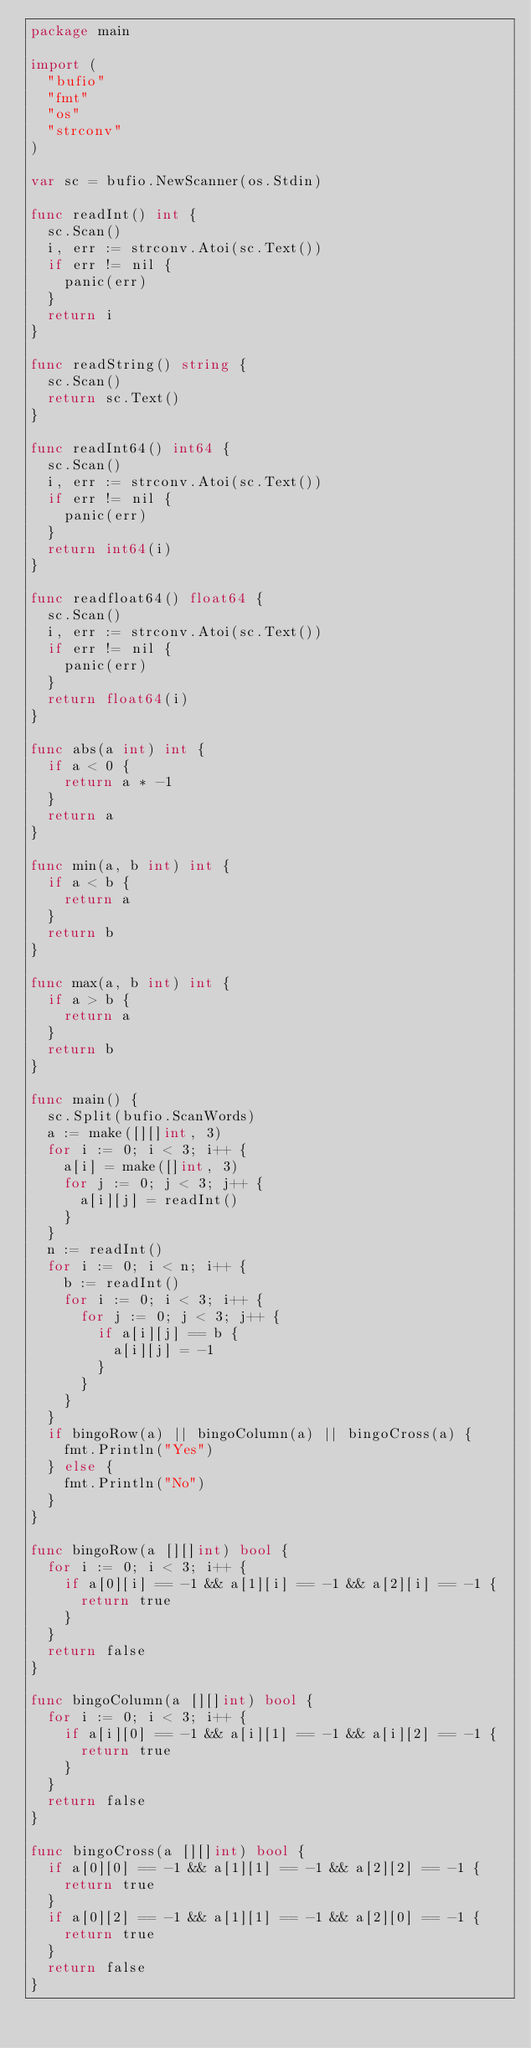Convert code to text. <code><loc_0><loc_0><loc_500><loc_500><_Go_>package main

import (
	"bufio"
	"fmt"
	"os"
	"strconv"
)

var sc = bufio.NewScanner(os.Stdin)

func readInt() int {
	sc.Scan()
	i, err := strconv.Atoi(sc.Text())
	if err != nil {
		panic(err)
	}
	return i
}

func readString() string {
	sc.Scan()
	return sc.Text()
}

func readInt64() int64 {
	sc.Scan()
	i, err := strconv.Atoi(sc.Text())
	if err != nil {
		panic(err)
	}
	return int64(i)
}

func readfloat64() float64 {
	sc.Scan()
	i, err := strconv.Atoi(sc.Text())
	if err != nil {
		panic(err)
	}
	return float64(i)
}

func abs(a int) int {
	if a < 0 {
		return a * -1
	}
	return a
}

func min(a, b int) int {
	if a < b {
		return a
	}
	return b
}

func max(a, b int) int {
	if a > b {
		return a
	}
	return b
}

func main() {
	sc.Split(bufio.ScanWords)
	a := make([][]int, 3)
	for i := 0; i < 3; i++ {
		a[i] = make([]int, 3)
		for j := 0; j < 3; j++ {
			a[i][j] = readInt()
		}
	}
	n := readInt()
	for i := 0; i < n; i++ {
		b := readInt()
		for i := 0; i < 3; i++ {
			for j := 0; j < 3; j++ {
				if a[i][j] == b {
					a[i][j] = -1
				}
			}
		}
	}
	if bingoRow(a) || bingoColumn(a) || bingoCross(a) {
		fmt.Println("Yes")
	} else {
		fmt.Println("No")
	}
}

func bingoRow(a [][]int) bool {
	for i := 0; i < 3; i++ {
		if a[0][i] == -1 && a[1][i] == -1 && a[2][i] == -1 {
			return true
		}
	}
	return false
}

func bingoColumn(a [][]int) bool {
	for i := 0; i < 3; i++ {
		if a[i][0] == -1 && a[i][1] == -1 && a[i][2] == -1 {
			return true
		}
	}
	return false
}

func bingoCross(a [][]int) bool {
	if a[0][0] == -1 && a[1][1] == -1 && a[2][2] == -1 {
		return true
	}
	if a[0][2] == -1 && a[1][1] == -1 && a[2][0] == -1 {
		return true
	}
	return false
}
</code> 